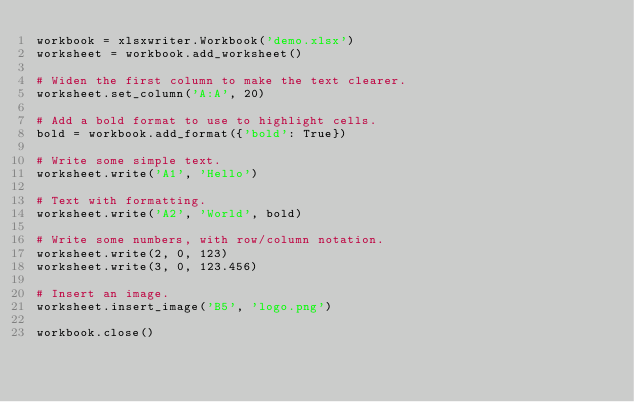<code> <loc_0><loc_0><loc_500><loc_500><_Python_>workbook = xlsxwriter.Workbook('demo.xlsx')
worksheet = workbook.add_worksheet()

# Widen the first column to make the text clearer.
worksheet.set_column('A:A', 20)

# Add a bold format to use to highlight cells.
bold = workbook.add_format({'bold': True})

# Write some simple text.
worksheet.write('A1', 'Hello')

# Text with formatting.
worksheet.write('A2', 'World', bold)

# Write some numbers, with row/column notation.
worksheet.write(2, 0, 123)
worksheet.write(3, 0, 123.456)

# Insert an image.
worksheet.insert_image('B5', 'logo.png')

workbook.close()
</code> 